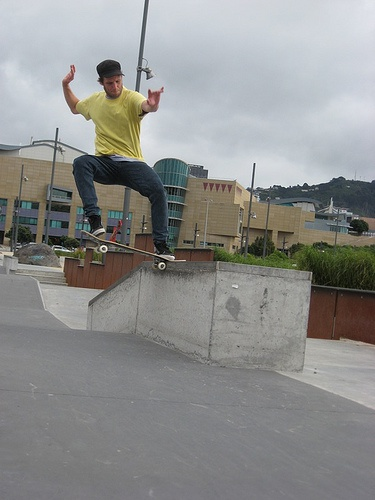Describe the objects in this image and their specific colors. I can see people in lightgray, black, olive, and gray tones, skateboard in lightgray, gray, black, and darkgray tones, and car in lightgray, gray, darkgray, and black tones in this image. 